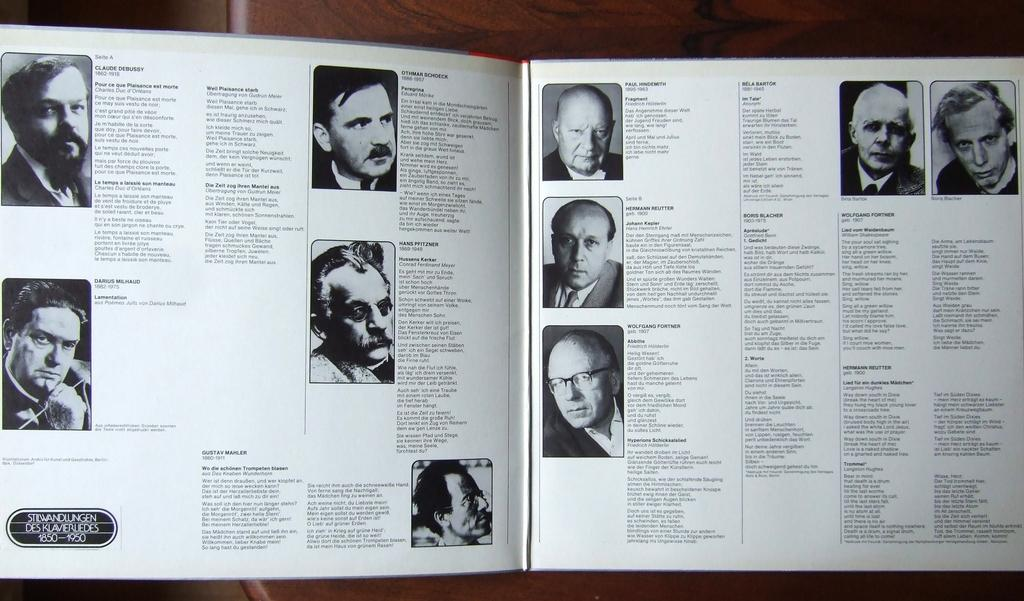What is the main object in the image? There is a book in the image. What type of content is featured in the book? The book contains images of men. Is there any text in the book? Yes, there is text on the pages of the book. What is the opinion of the bed in the image? There is no bed present in the image, so it is not possible to determine its opinion. 